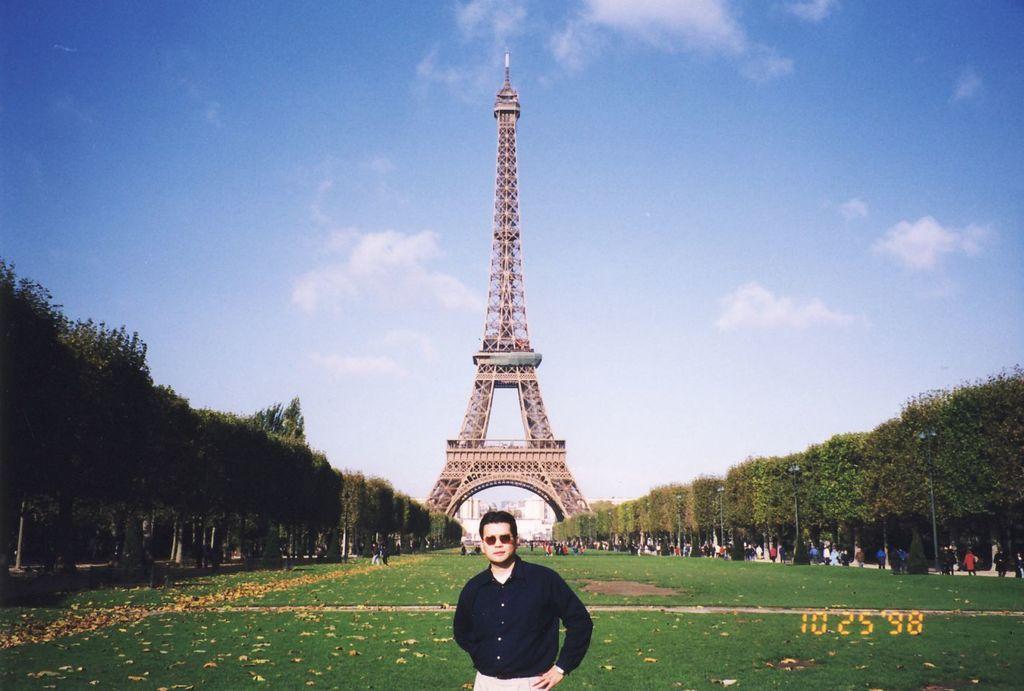Could you give a brief overview of what you see in this image? In this picture there is a person wearing black shirt is standing and there are trees on either sides of him and there are few persons standing in the right corner. 